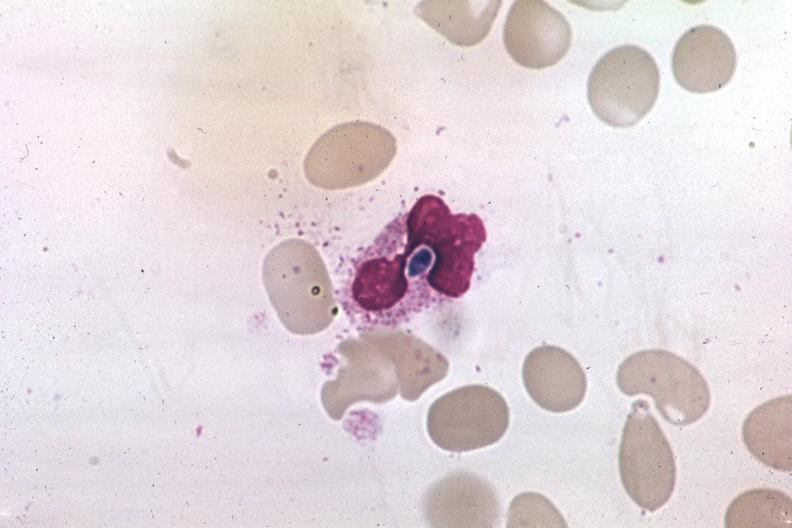s retroperitoneum present?
Answer the question using a single word or phrase. No 